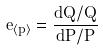Convert formula to latex. <formula><loc_0><loc_0><loc_500><loc_500>e _ { \langle p \rangle } = \frac { d Q / Q } { d P / P }</formula> 